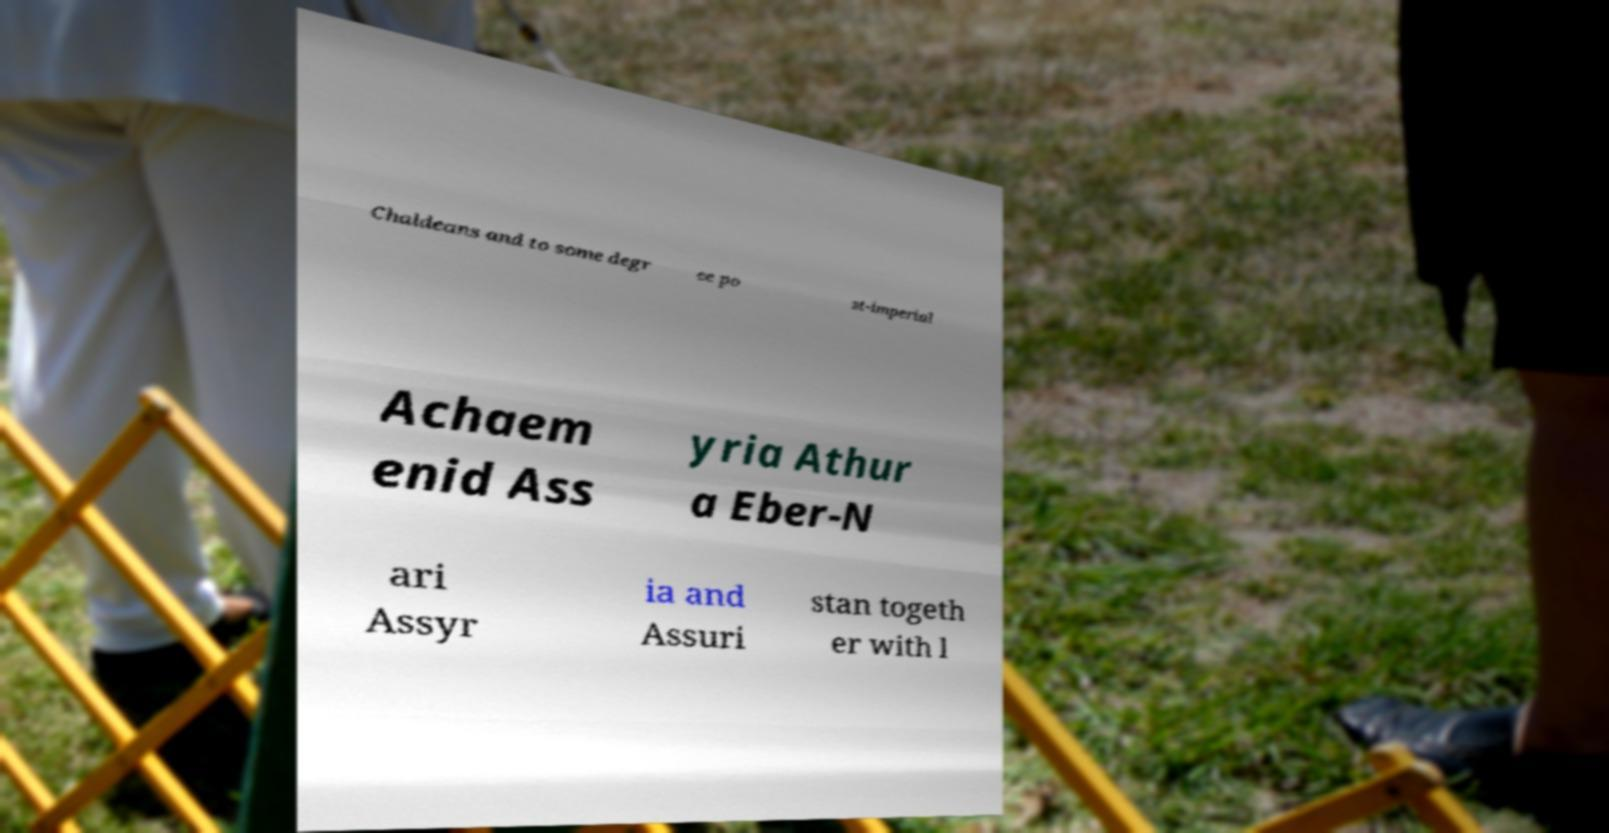Can you accurately transcribe the text from the provided image for me? Chaldeans and to some degr ee po st-imperial Achaem enid Ass yria Athur a Eber-N ari Assyr ia and Assuri stan togeth er with l 